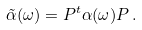Convert formula to latex. <formula><loc_0><loc_0><loc_500><loc_500>\tilde { \alpha } ( \omega ) = P ^ { t } \alpha ( \omega ) P \, .</formula> 